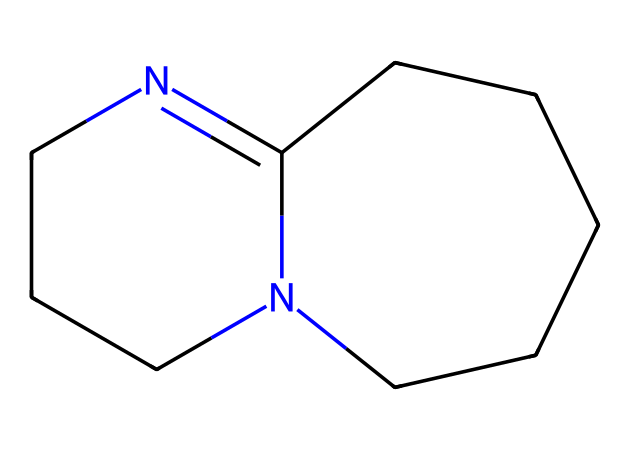What is the molecular formula of DBU? To determine the molecular formula, we can count the number of each type of atom represented in the SMILES notation. The structure contains 11 carbon (C), 16 hydrogen (H), and 2 nitrogen (N) atoms, leading to the molecular formula C11H16N2.
Answer: C11H16N2 How many nitrogen atoms are present in DBU? In the molecular structure indicated by the SMILES notation, we can directly identify the presence of two nitrogen atoms based on the notation itself.
Answer: 2 Is 1,8-diazabicyclo[5.4.0]undec-7-ene a cyclic compound? The presence of two fused rings in the name indicates that DBU has a bicyclic structure, confirming it is indeed a cyclic compound.
Answer: Yes What type of functional groups are present in DBU? Examining the structure, DBU features a bipyridine-like arrangement where two nitrogen atoms act as bases, indicating the presence of amine groups, specifically tertiary amines.
Answer: Amine What is the primary use of DBU in cleaning products? DBU's strong basicity enables it to effectively neutralize acids and break down organic compounds, making it a useful ingredient in many cleaning products.
Answer: Cleaning How does the structure of DBU contribute to its basicity? The bicyclic structure allows for the lone pair of electrons from the nitrogen atoms to be delocalized, increasing the availability of those electrons for protonation, thus enhancing its basic properties.
Answer: Delocalization of electrons Can DBU act as a nucleophile? Due to the lone pairs on the nitrogen atoms, DBU has the ability to donate electrons, making it a capable nucleophile in chemical reactions.
Answer: Yes 